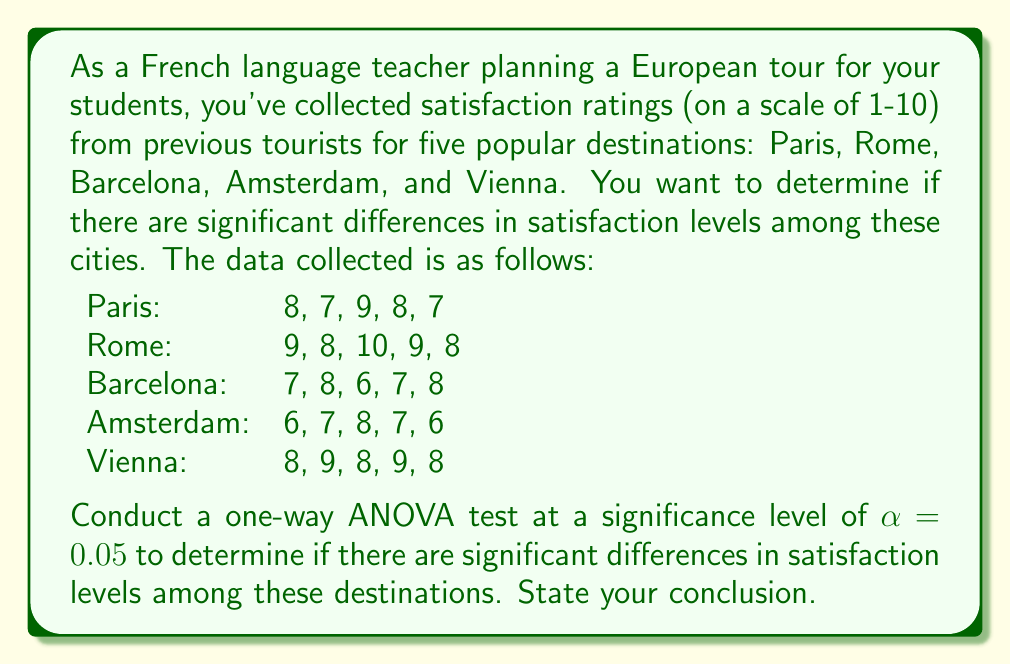Help me with this question. Let's approach this step-by-step using one-way ANOVA:

1) First, let's calculate the means for each group:
   Paris: $\bar{x}_1 = 7.8$
   Rome: $\bar{x}_2 = 8.8$
   Barcelona: $\bar{x}_3 = 7.2$
   Amsterdam: $\bar{x}_4 = 6.8$
   Vienna: $\bar{x}_5 = 8.4$

2) Calculate the grand mean:
   $\bar{x} = \frac{7.8 + 8.8 + 7.2 + 6.8 + 8.4}{5} = 7.8$

3) Calculate SSB (Sum of Squares Between groups):
   $$SSB = \sum_{i=1}^k n_i(\bar{x}_i - \bar{x})^2$$
   $$SSB = 5[(7.8-7.8)^2 + (8.8-7.8)^2 + (7.2-7.8)^2 + (6.8-7.8)^2 + (8.4-7.8)^2]$$
   $$SSB = 5(0 + 1 + 0.36 + 1 + 0.36) = 13.6$$

4) Calculate SSW (Sum of Squares Within groups):
   $$SSW = \sum_{i=1}^k \sum_{j=1}^{n_i} (x_{ij} - \bar{x}_i)^2$$
   Paris: $(8-7.8)^2 + (7-7.8)^2 + (9-7.8)^2 + (8-7.8)^2 + (7-7.8)^2 = 2.8$
   Rome: $(9-8.8)^2 + (8-8.8)^2 + (10-8.8)^2 + (9-8.8)^2 + (8-8.8)^2 = 2.8$
   Barcelona: $(7-7.2)^2 + (8-7.2)^2 + (6-7.2)^2 + (7-7.2)^2 + (8-7.2)^2 = 2.8$
   Amsterdam: $(6-6.8)^2 + (7-6.8)^2 + (8-6.8)^2 + (7-6.8)^2 + (6-6.8)^2 = 2.8$
   Vienna: $(8-8.4)^2 + (9-8.4)^2 + (8-8.4)^2 + (9-8.4)^2 + (8-8.4)^2 = 1.2$
   $$SSW = 2.8 + 2.8 + 2.8 + 2.8 + 1.2 = 12.4$$

5) Calculate degrees of freedom:
   $df_{between} = k - 1 = 5 - 1 = 4$
   $df_{within} = N - k = 25 - 5 = 20$

6) Calculate Mean Square Between (MSB) and Mean Square Within (MSW):
   $$MSB = \frac{SSB}{df_{between}} = \frac{13.6}{4} = 3.4$$
   $$MSW = \frac{SSW}{df_{within}} = \frac{12.4}{20} = 0.62$$

7) Calculate F-statistic:
   $$F = \frac{MSB}{MSW} = \frac{3.4}{0.62} = 5.48$$

8) Find the critical F-value:
   For $\alpha = 0.05$, $df_{between} = 4$, and $df_{within} = 20$, the critical F-value is approximately 2.87.

9) Compare F-statistic to critical F-value:
   Since $5.48 > 2.87$, we reject the null hypothesis.
Answer: The F-statistic (5.48) is greater than the critical F-value (2.87), so we reject the null hypothesis at $\alpha = 0.05$. We conclude that there are significant differences in satisfaction levels among the five European destinations. This suggests that, as a French language teacher planning a tour, you should consider these differences when choosing destinations for your students. 